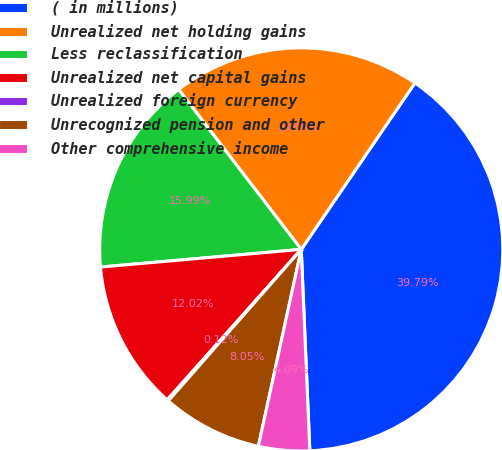Convert chart. <chart><loc_0><loc_0><loc_500><loc_500><pie_chart><fcel>( in millions)<fcel>Unrealized net holding gains<fcel>Less reclassification<fcel>Unrealized net capital gains<fcel>Unrealized foreign currency<fcel>Unrecognized pension and other<fcel>Other comprehensive income<nl><fcel>39.79%<fcel>19.95%<fcel>15.99%<fcel>12.02%<fcel>0.12%<fcel>8.05%<fcel>4.09%<nl></chart> 